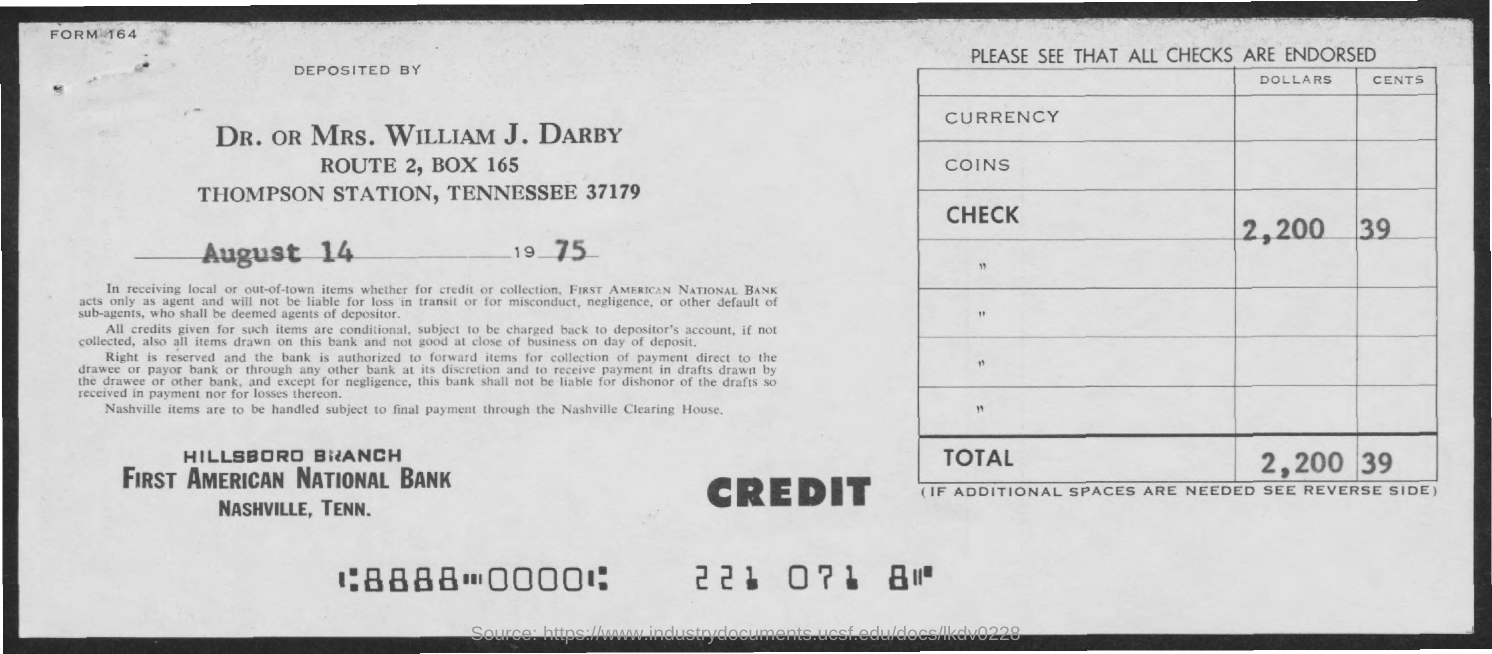What is the Form No. given in the header of the document?
Give a very brief answer. 164. Who has deposited the check amount as per the form?
Your response must be concise. DR. OR MRS. WILLIAM J. DARBY. What is the deposit date mentioned in the form?
Offer a very short reply. August 14 1975. What is the check amount (in dollars.cents) mentioned in the form?
Give a very brief answer. 2,200.39. Which bank's form is given here?
Provide a short and direct response. FIRST AMERICAN NATIONAL BANK. 